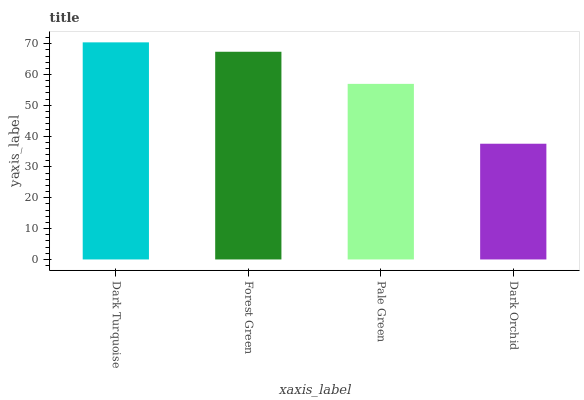Is Forest Green the minimum?
Answer yes or no. No. Is Forest Green the maximum?
Answer yes or no. No. Is Dark Turquoise greater than Forest Green?
Answer yes or no. Yes. Is Forest Green less than Dark Turquoise?
Answer yes or no. Yes. Is Forest Green greater than Dark Turquoise?
Answer yes or no. No. Is Dark Turquoise less than Forest Green?
Answer yes or no. No. Is Forest Green the high median?
Answer yes or no. Yes. Is Pale Green the low median?
Answer yes or no. Yes. Is Pale Green the high median?
Answer yes or no. No. Is Forest Green the low median?
Answer yes or no. No. 